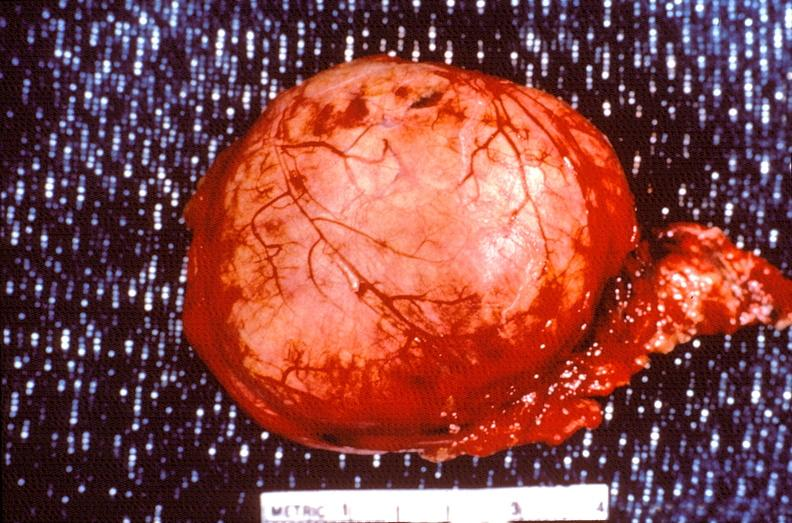does this image show pituitary, chromaphobe adenoma?
Answer the question using a single word or phrase. Yes 